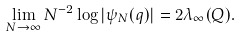<formula> <loc_0><loc_0><loc_500><loc_500>\lim _ { N \to \infty } N ^ { - 2 } \log | \psi _ { N } ( q ) | = 2 \lambda _ { \infty } ( Q ) .</formula> 